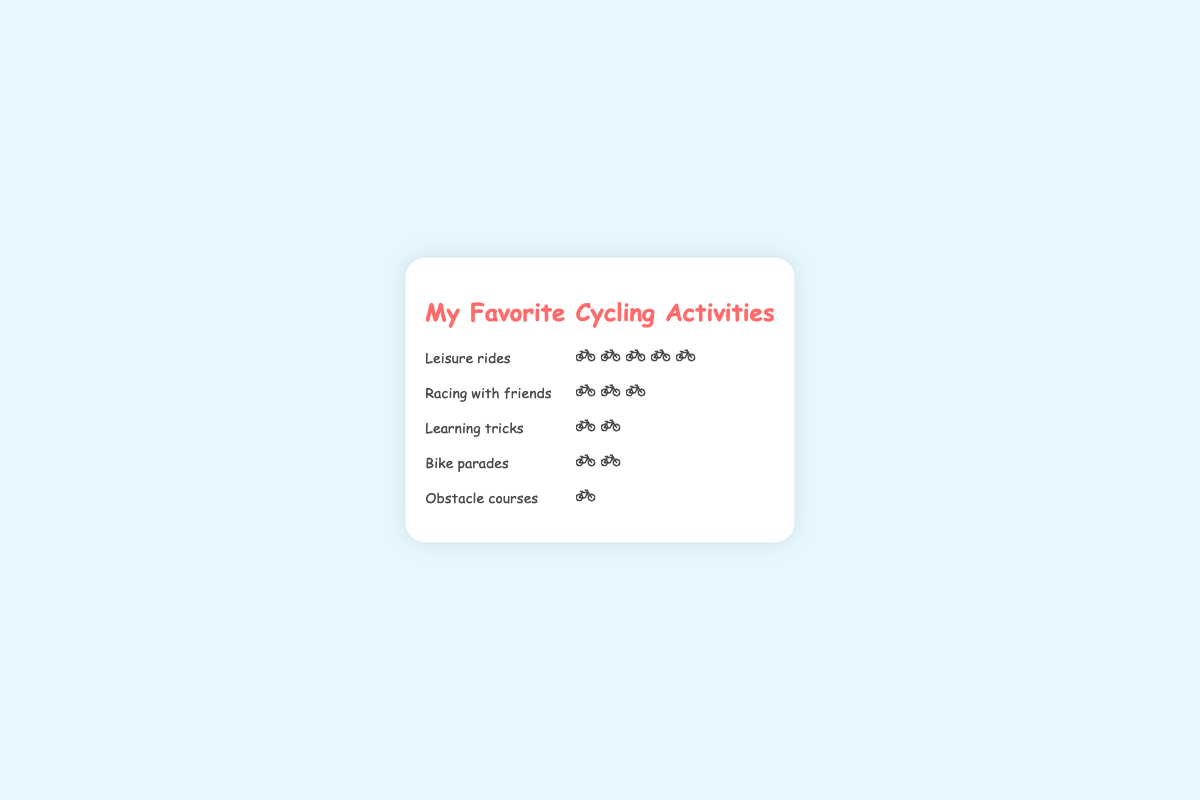What is the most popular cycling activity among children aged 5-12? The most popular cycling activity can be determined by the activity with the most icons. "Leisure rides" has the most icons, which are five bikes.
Answer: Leisure rides How many more children prefer "Leisure rides" than "Racing with friends"? To find the difference, observe the number of icons for each activity: "Leisure rides" has 5 bikes, and "Racing with friends" has 3 bikes. The difference is 5 - 3 = 2 icons (representing 20 more children).
Answer: 20 Which activity is the least popular? The least popular activity will have the fewest icons. "Obstacle courses" has only one bike icon, making it the least popular.
Answer: Obstacle courses What is the total number of children from the top two favorite activities? First, identify the top two activities: "Leisure rides" (50 children) and "Racing with friends" (30 children). Add the counts: 50 + 30 = 80.
Answer: 80 How many activities have more than two bike icons? Count the activities that have more than two bike icons: "Leisure rides" (5 bikes) and "Racing with friends" (3 bikes). There are two such activities.
Answer: 2 Which activities have an equal number of bike icons? Look for activities with the same number of icons: "Learning tricks" and "Bike parades" both have 2 bike icons each.
Answer: Learning tricks and Bike parades What percentage of children prefer "Obstacle courses" compared to those who prefer "Leisure rides"? Calculate the percentage by dividing the number of children preferring "Obstacle courses" (10) by those preferring "Leisure rides" (50) and multiplying by 100: (10 / 50) * 100 = 20%.
Answer: 20% If 10 more children start liking "Bike parades", how will the number of bike icons change? "Bike parades" currently has 2 bikes (for 15 children). Adding 10 more children, it becomes 25 children, which would be represented by 2.5 icons. Since icons usually represent whole numbers, it might be reflected as 3 bike icons (rounded up).
Answer: 3 Which activity is more popular: "Learning tricks" or "Bike parades"? Compare the number of icons: Both "Learning tricks" and "Bike parades" have 2 bike icons each, representing the same level of popularity.
Answer: Both activities are equally popular 